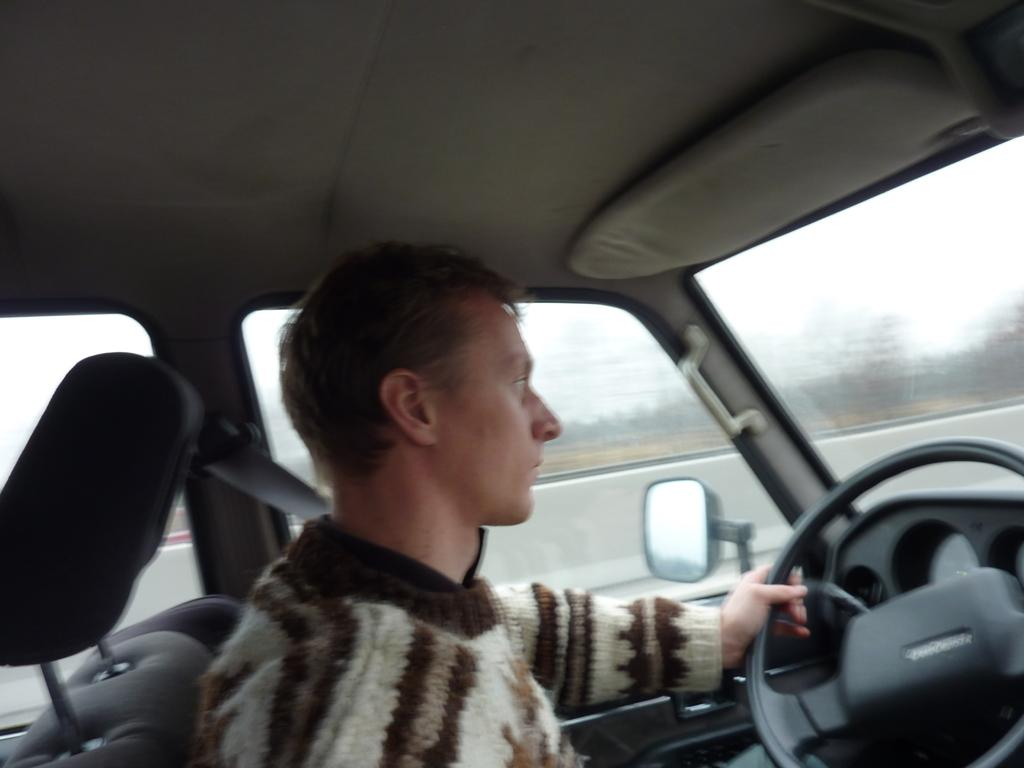What is the main subject of the image? The main subject of the image is a person driving a car. Can you describe the background of the image? The background of the image is blurry. What type of paper is the person wearing as a skirt in the image? There is no paper or skirt present in the image; it features a person driving a car. What type of juice is the person holding in the image? There is no juice present in the image; it features a person driving a car. 